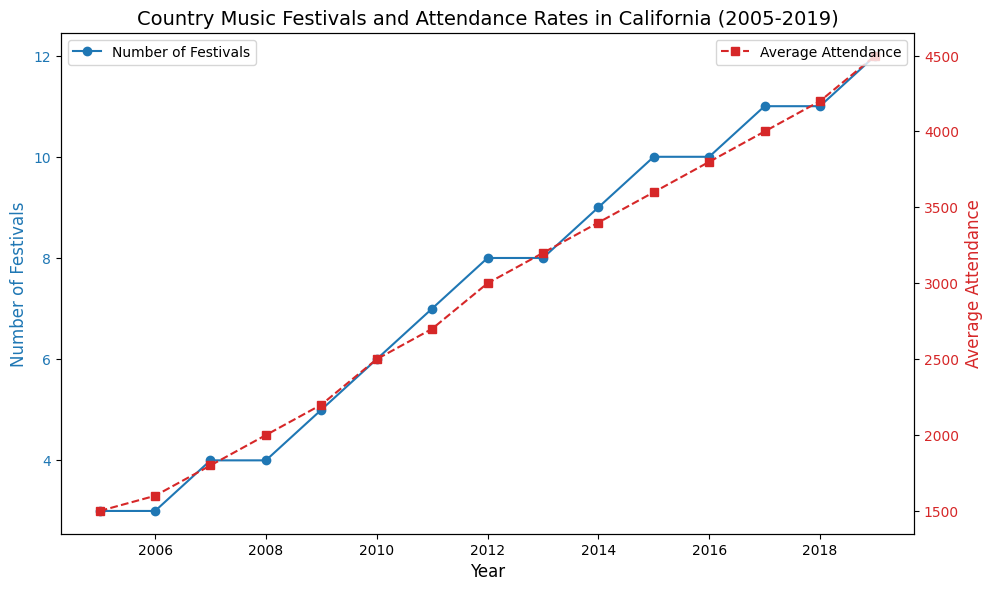How many more festivals were there in 2019 compared to 2005? In 2005, there were 3 festivals, and in 2019, there were 12 festivals. The difference is calculated as 12 - 3 = 9
Answer: 9 By how much did the average attendance increase from 2005 to 2019? The average attendance in 2005 was 1500, and in 2019, it was 4500. The increase is calculated as 4500 - 1500 = 3000
Answer: 3000 In which year did the average attendance first exceed 3000? From the graph, the average attendance first exceeds 3000 in the year 2012
Answer: 2012 How many years did it take for the number of festivals to double from the value in 2005? In 2005, there were 3 festivals. Doubling this gives us 6 festivals. In 2010, there were 6 festivals, thus it took 2010 - 2005 = 5 years
Answer: 5 years Which year had the greatest increase in the number of festivals compared to the previous year? The biggest increase was from 2008 to 2009, where the number of festivals increased from 4 to 5
Answer: 2009 Compared to 2015, what was the percentage increase in average attendance in 2019? In 2015, the average attendance was 3600, and in 2019, it was 4500. The percentage increase is calculated as ((4500 - 3600) / 3600) * 100 = 25%
Answer: 25% How many years had an equal number of festivals? The years 2005 and 2006 both had 3 festivals, and the years 2013 and 2014 both had 8 festivals. Thus, 2 periods (2005-2006 and 2013-2014) had equal numbers of festivals
Answer: 2 What is the average number of festivals between 2005 and 2019? Sum the number of festivals from 2005 to 2019 and divide by 15 (the total number of years). (3+3+4+4+5+6+7+8+8+9+10+10+11+11+12)/15 = 133/15 = 8.87
Answer: 8.87 During which period did the average attendance grow the fastest? The steepest slope on the attendance graph is between 2018 and 2019 where the average attendance grew from 4200 to 4500. The growth is calculated as (4500 - 4200) in 1 year = 300
Answer: 2018-2019 Was there any year when both the number of festivals and average attendance did not increase from the previous year? The graphical trend shows consistent growth in both lines for every consecutive year from 2005 to 2019, meaning there's no such year where both metrics did not increase
Answer: No 